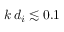<formula> <loc_0><loc_0><loc_500><loc_500>k \, d _ { i } \lesssim 0 . 1</formula> 